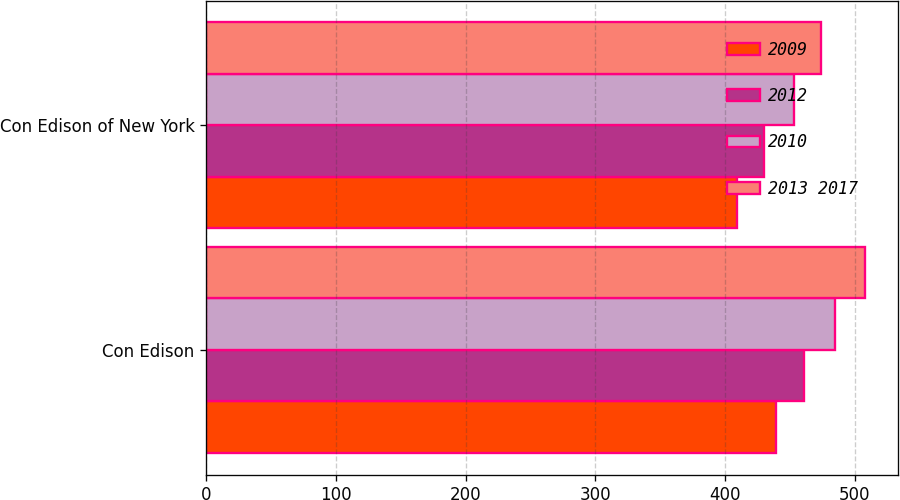<chart> <loc_0><loc_0><loc_500><loc_500><stacked_bar_chart><ecel><fcel>Con Edison<fcel>Con Edison of New York<nl><fcel>2009<fcel>439<fcel>409<nl><fcel>2012<fcel>461<fcel>430<nl><fcel>2010<fcel>485<fcel>453<nl><fcel>2013 2017<fcel>508<fcel>474<nl></chart> 